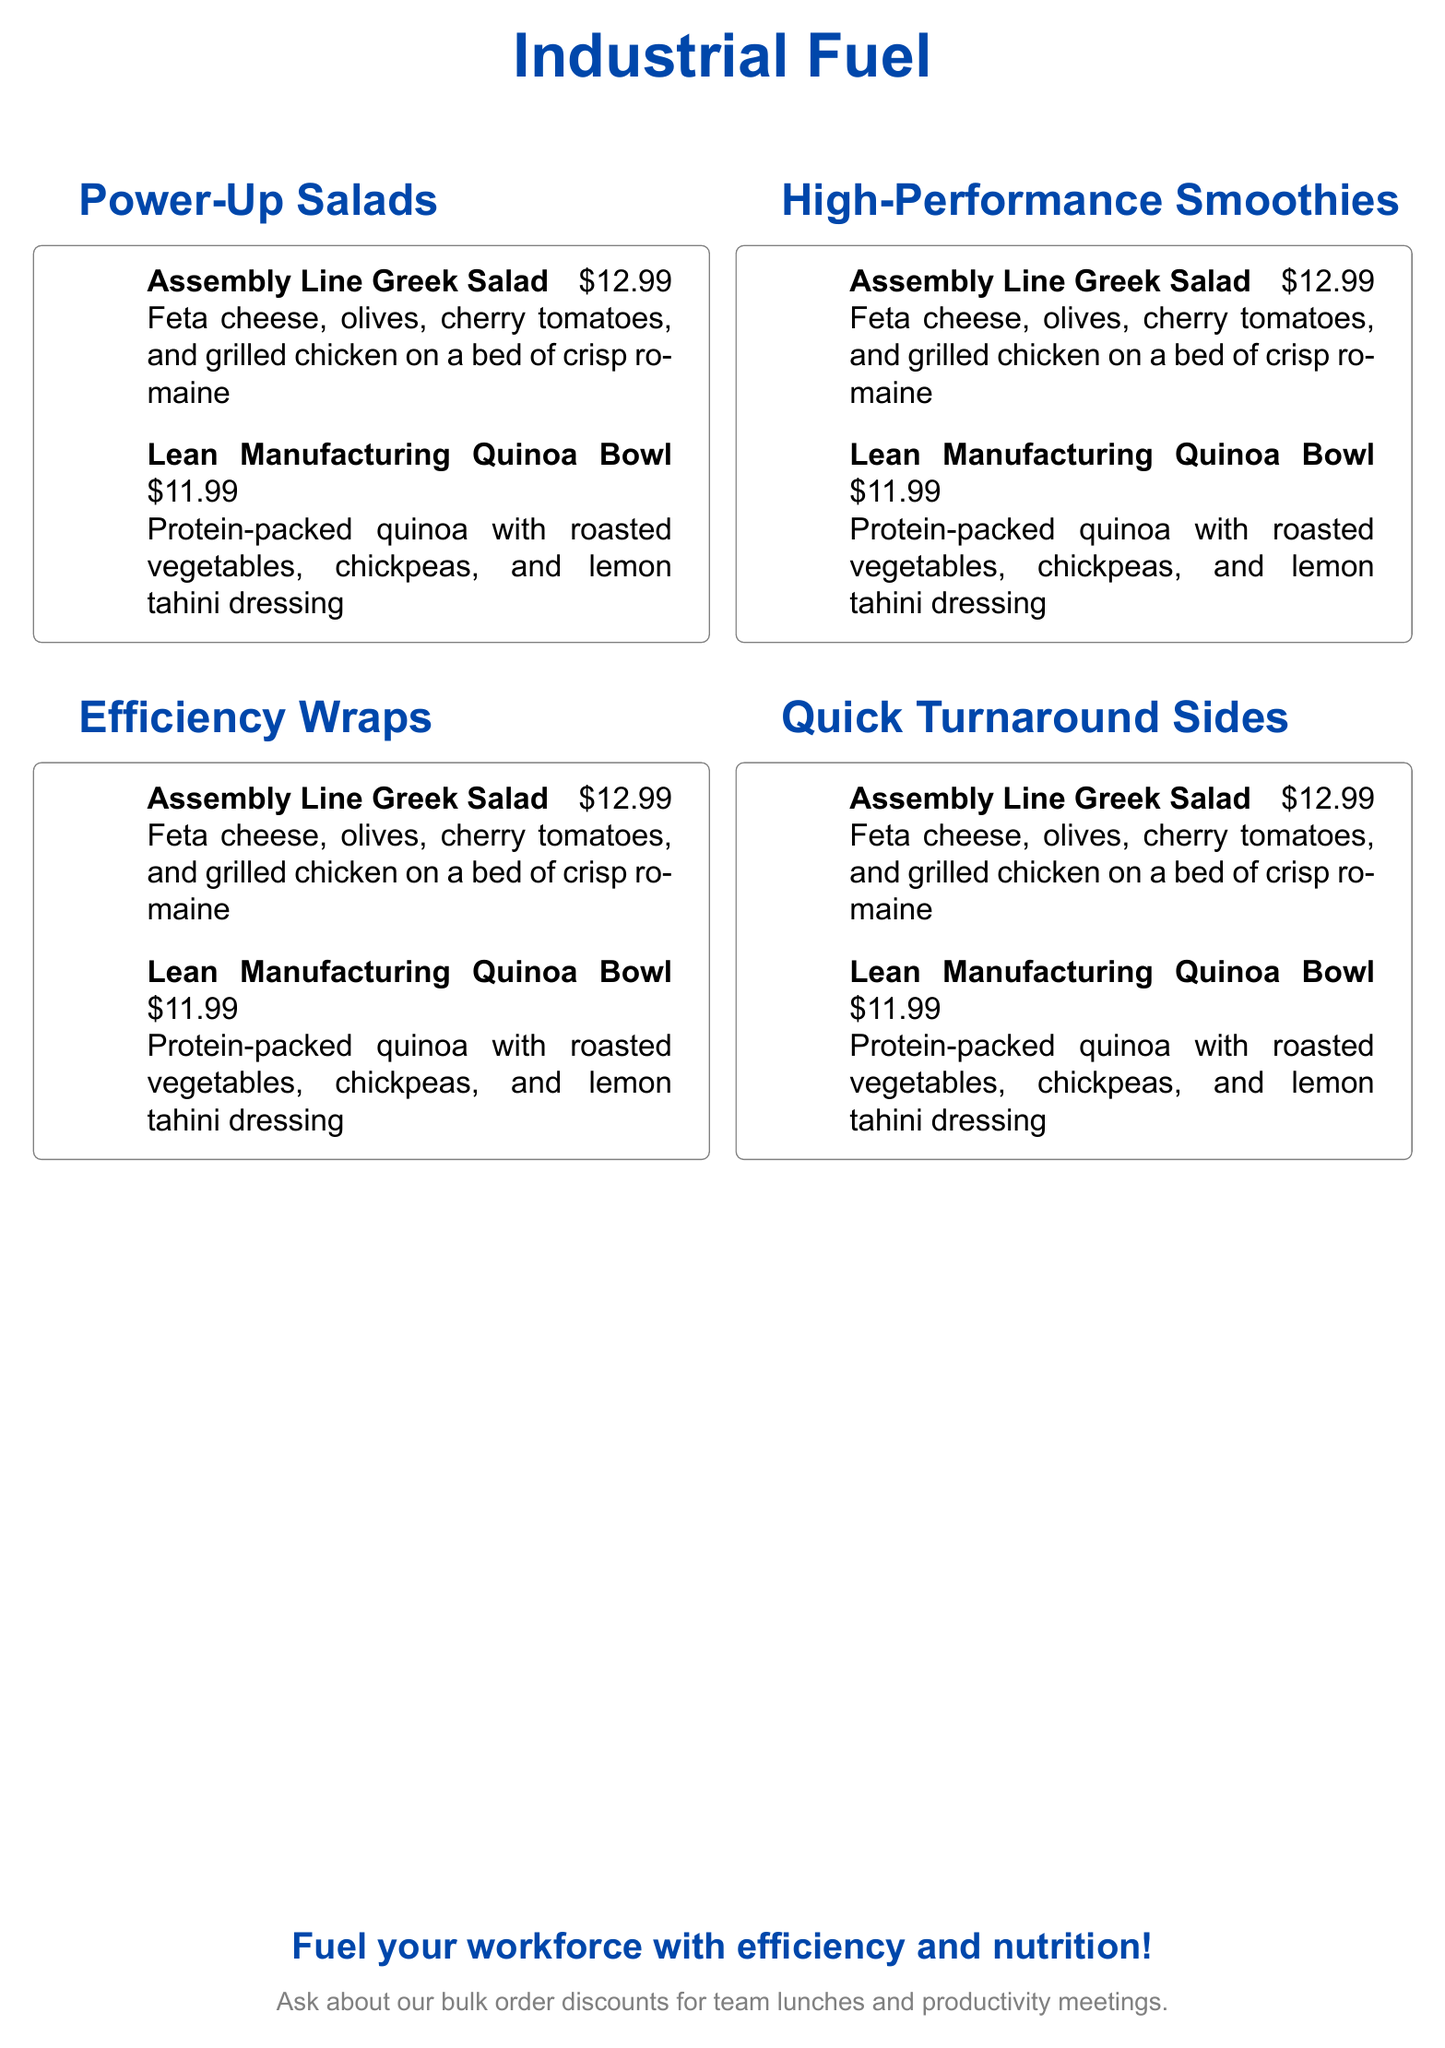What are the two sections of the menu? The document has sections titled "Power-Up Salads" and "Efficiency Wraps".
Answer: Power-Up Salads, Efficiency Wraps What is the price of the Lean Manufacturing Quinoa Bowl? The price for the Lean Manufacturing Quinoa Bowl is clearly stated in the menu.
Answer: $11.99 How many items are listed under the Power-Up Salads section? There are two items listed in the Power-Up Salads section of the menu.
Answer: 2 What type of cheese is in the Assembly Line Greek Salad? The menu specifies that feta cheese is included in the Assembly Line Greek Salad.
Answer: Feta cheese What is the main ingredient of the Lean Manufacturing Quinoa Bowl? The main ingredient of the Lean Manufacturing Quinoa Bowl is highlighted in the menu's description.
Answer: Quinoa What dressings are used in the Lean Manufacturing Quinoa Bowl? The menu states that lemon tahini dressing is used in the Lean Manufacturing Quinoa Bowl.
Answer: Lemon tahini dressing Are there discounts available for bulk orders? The menu mentions the availability of discounts for bulk orders.
Answer: Yes Which phrase is used to promote the menu's offerings? The promotional phrase is part of the concluding statement at the bottom of the document.
Answer: Fuel your workforce with efficiency and nutrition! 